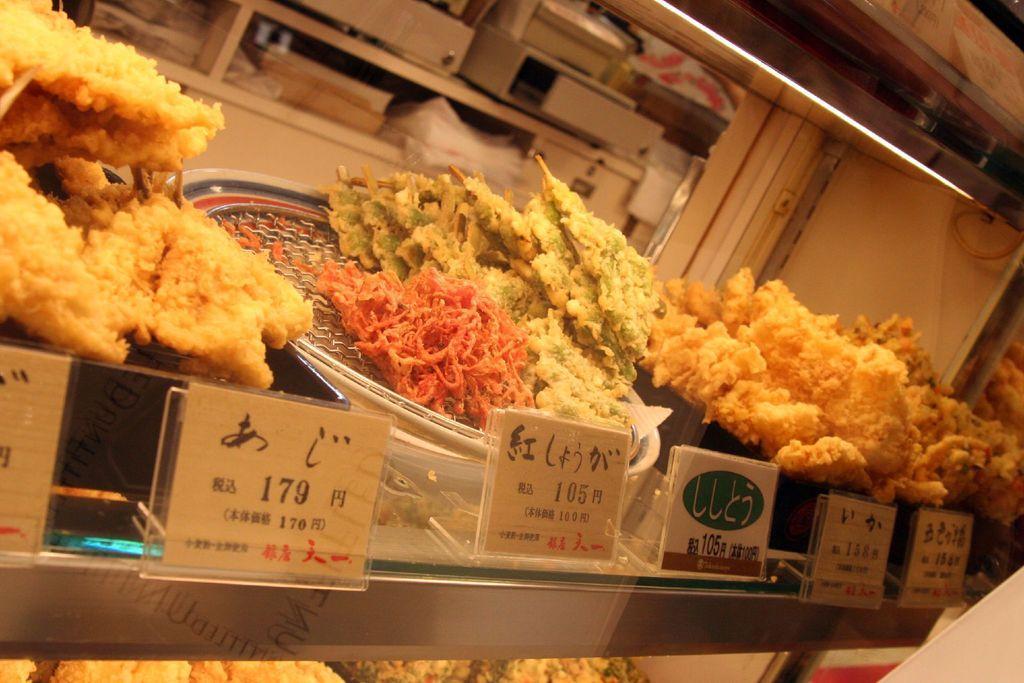Describe this image in one or two sentences. In this image I can see few plates and in them I can see few food items which are orange, green, cream and brown in color. I can see few white colored boards in front of them. In the background I can see a light, few racks and few objects in the racks. 